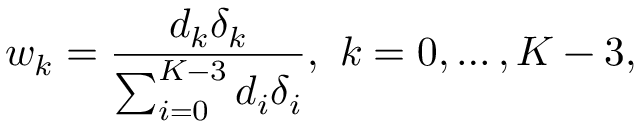Convert formula to latex. <formula><loc_0><loc_0><loc_500><loc_500>w _ { k } = \frac { d _ { k } \delta _ { k } } { \sum _ { i = 0 } ^ { K - 3 } d _ { i } \delta _ { i } } , k = 0 , \dots , K - 3 ,</formula> 